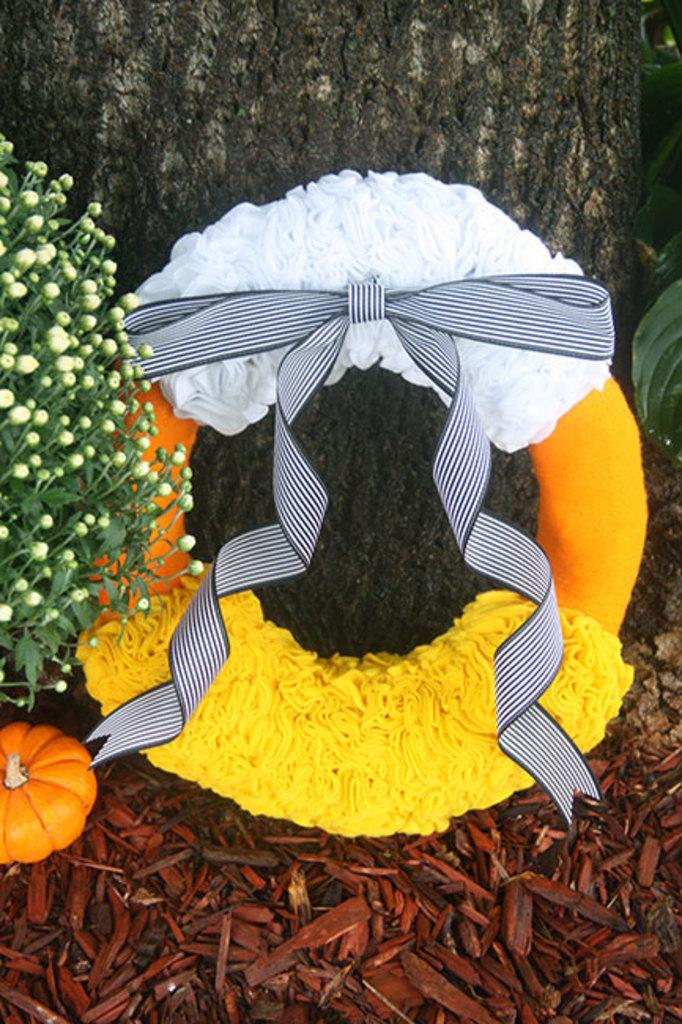What is the decorated object in the image? The facts do not specify the type of object, but it is decorated and present in the image. What is located behind the decorated object? There is a tree trunk behind the object. What type of vegetation is in the image? There is a plant in the image. What is beside the decorated object? There is a pumpkin beside the object. What type of coal is being used to heat the room in the image? There is no mention of coal or a room in the image; it features a decorated object, a tree trunk, a plant, and a pumpkin. 